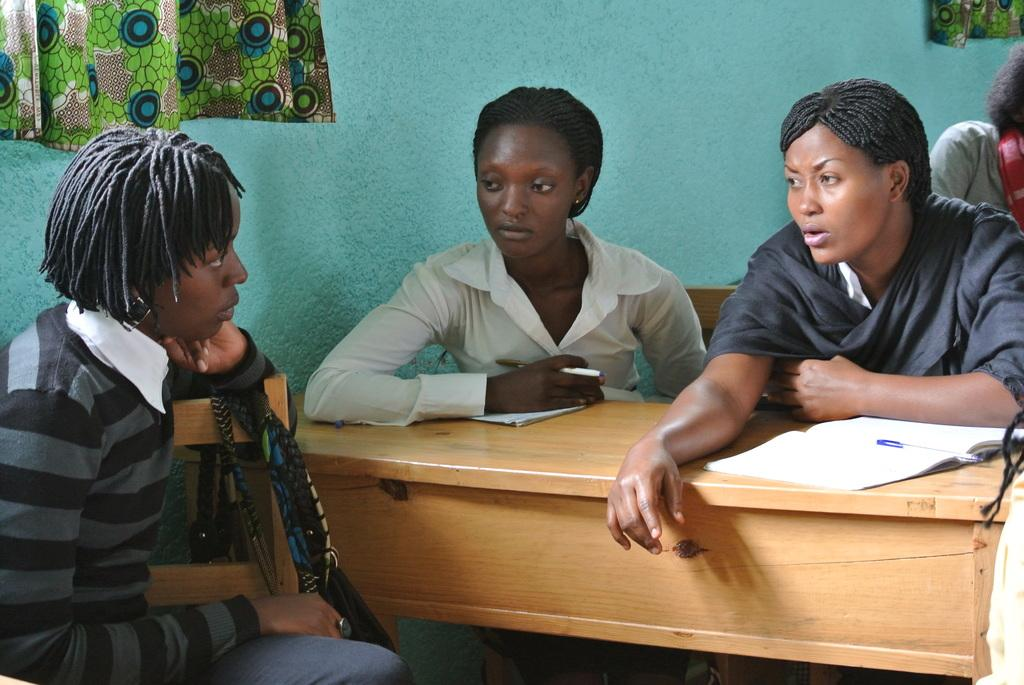What are the people in the image doing? The persons in the image are sitting on chairs near to the table. What items can be seen on the table? There are books and pens on the table. What can be seen in the background of the picture? There is a wall and curtains in the background of the picture. Can you tell me where the girl is sitting in the image? There is no girl mentioned or visible in the image. What type of scissors are being used by the persons in the image? There are no scissors present in the image. 